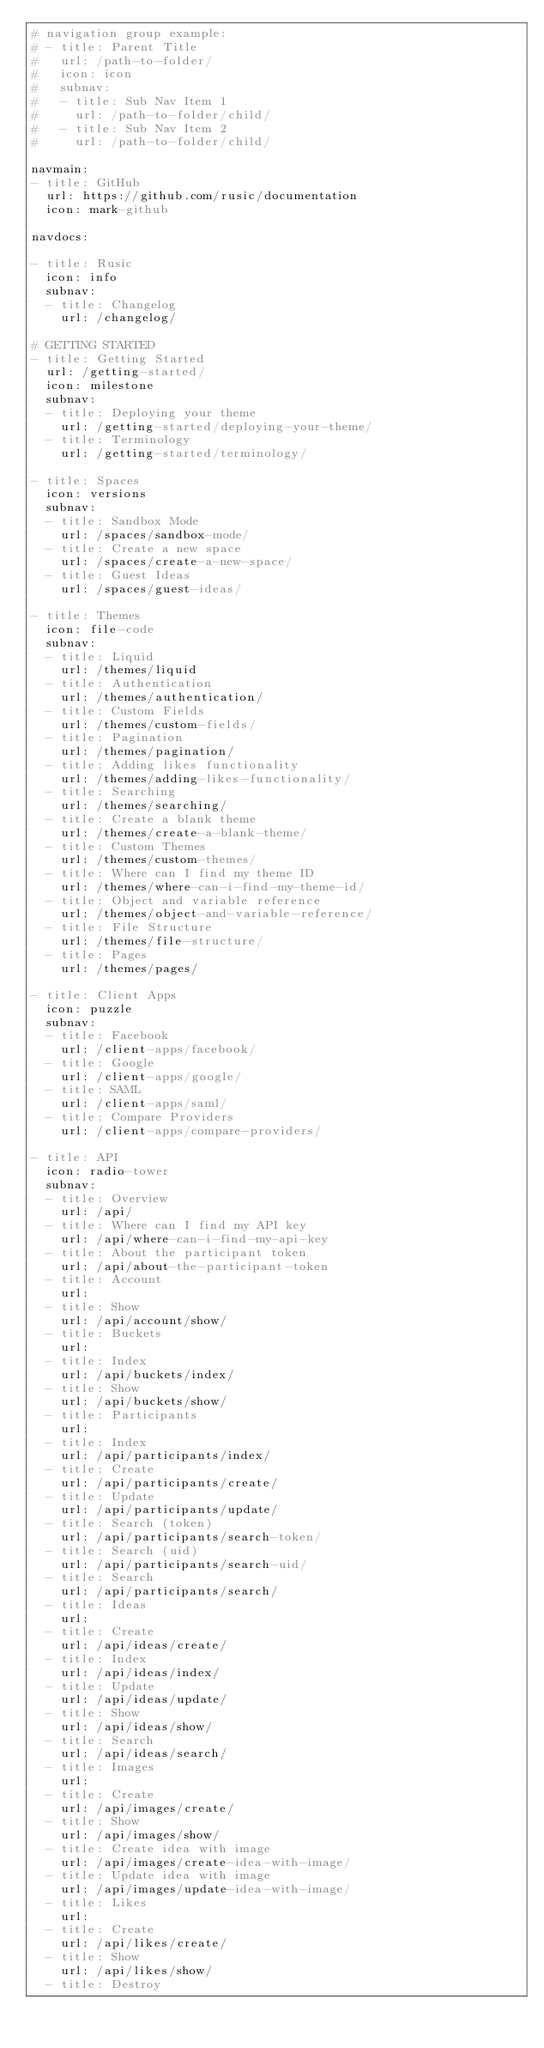Convert code to text. <code><loc_0><loc_0><loc_500><loc_500><_YAML_># navigation group example:
# - title: Parent Title
#   url: /path-to-folder/
#   icon: icon
#   subnav:
#   - title: Sub Nav Item 1
#     url: /path-to-folder/child/
#   - title: Sub Nav Item 2
#     url: /path-to-folder/child/

navmain:
- title: GitHub
  url: https://github.com/rusic/documentation
  icon: mark-github

navdocs:

- title: Rusic
  icon: info
  subnav:
  - title: Changelog
    url: /changelog/

# GETTING STARTED
- title: Getting Started
  url: /getting-started/
  icon: milestone
  subnav:
  - title: Deploying your theme
    url: /getting-started/deploying-your-theme/
  - title: Terminology
    url: /getting-started/terminology/

- title: Spaces
  icon: versions
  subnav:
  - title: Sandbox Mode
    url: /spaces/sandbox-mode/
  - title: Create a new space
    url: /spaces/create-a-new-space/
  - title: Guest Ideas
    url: /spaces/guest-ideas/

- title: Themes
  icon: file-code
  subnav:
  - title: Liquid
    url: /themes/liquid
  - title: Authentication
    url: /themes/authentication/
  - title: Custom Fields
    url: /themes/custom-fields/
  - title: Pagination
    url: /themes/pagination/
  - title: Adding likes functionality
    url: /themes/adding-likes-functionality/
  - title: Searching
    url: /themes/searching/
  - title: Create a blank theme
    url: /themes/create-a-blank-theme/
  - title: Custom Themes
    url: /themes/custom-themes/
  - title: Where can I find my theme ID
    url: /themes/where-can-i-find-my-theme-id/
  - title: Object and variable reference
    url: /themes/object-and-variable-reference/
  - title: File Structure
    url: /themes/file-structure/
  - title: Pages
    url: /themes/pages/

- title: Client Apps
  icon: puzzle
  subnav:
  - title: Facebook
    url: /client-apps/facebook/
  - title: Google
    url: /client-apps/google/
  - title: SAML
    url: /client-apps/saml/
  - title: Compare Providers
    url: /client-apps/compare-providers/

- title: API
  icon: radio-tower
  subnav:
  - title: Overview
    url: /api/
  - title: Where can I find my API key
    url: /api/where-can-i-find-my-api-key
  - title: About the participant token
    url: /api/about-the-participant-token
  - title: Account
    url:
  - title: Show
    url: /api/account/show/
  - title: Buckets
    url:
  - title: Index
    url: /api/buckets/index/
  - title: Show
    url: /api/buckets/show/
  - title: Participants
    url:
  - title: Index
    url: /api/participants/index/
  - title: Create
    url: /api/participants/create/
  - title: Update
    url: /api/participants/update/
  - title: Search (token)
    url: /api/participants/search-token/
  - title: Search (uid)
    url: /api/participants/search-uid/
  - title: Search
    url: /api/participants/search/
  - title: Ideas
    url:
  - title: Create
    url: /api/ideas/create/
  - title: Index
    url: /api/ideas/index/
  - title: Update
    url: /api/ideas/update/
  - title: Show
    url: /api/ideas/show/
  - title: Search
    url: /api/ideas/search/
  - title: Images
    url:
  - title: Create
    url: /api/images/create/
  - title: Show
    url: /api/images/show/
  - title: Create idea with image
    url: /api/images/create-idea-with-image/
  - title: Update idea with image
    url: /api/images/update-idea-with-image/
  - title: Likes
    url:
  - title: Create
    url: /api/likes/create/
  - title: Show
    url: /api/likes/show/
  - title: Destroy</code> 